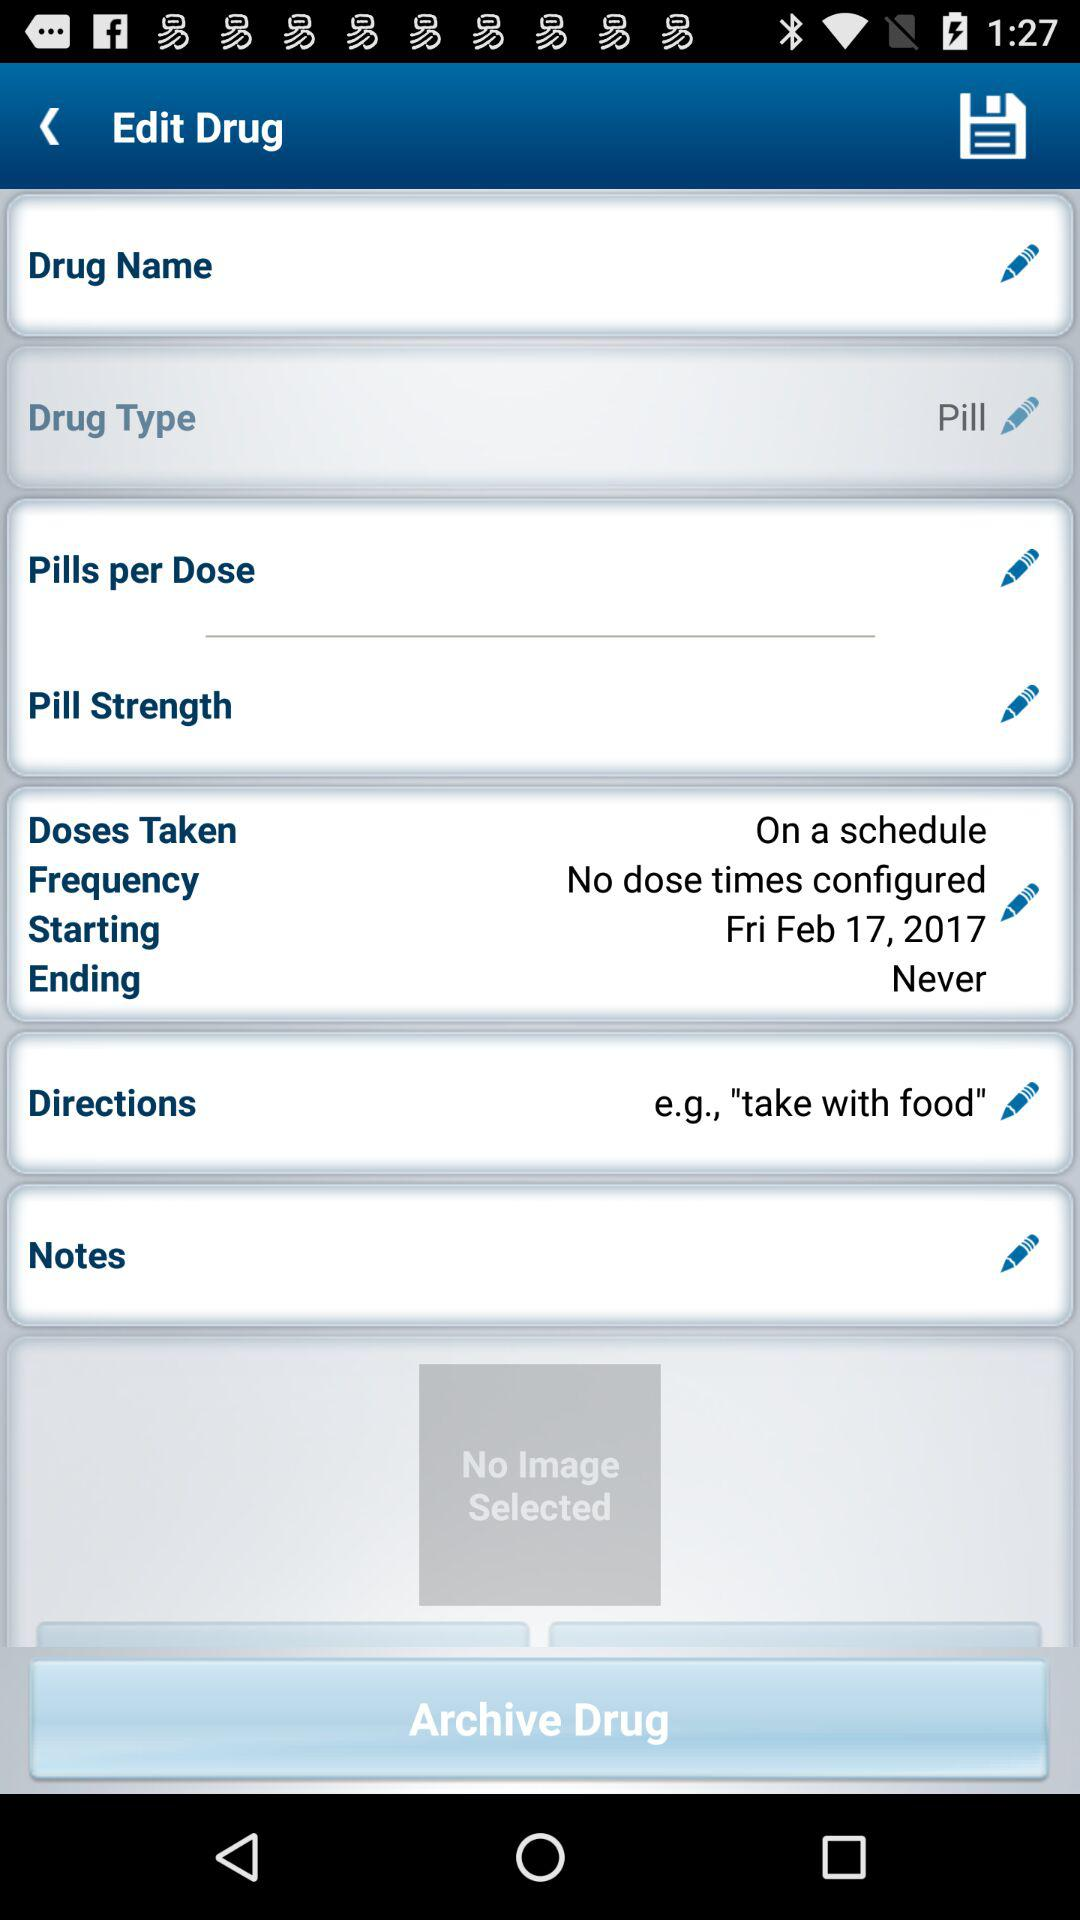What is the drug type? The drug type is "Pill". 